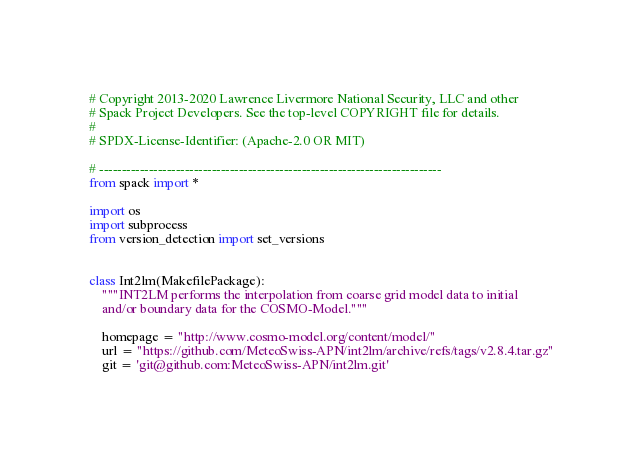Convert code to text. <code><loc_0><loc_0><loc_500><loc_500><_Python_># Copyright 2013-2020 Lawrence Livermore National Security, LLC and other
# Spack Project Developers. See the top-level COPYRIGHT file for details.
#
# SPDX-License-Identifier: (Apache-2.0 OR MIT)

# ----------------------------------------------------------------------------
from spack import *

import os
import subprocess
from version_detection import set_versions


class Int2lm(MakefilePackage):
    """INT2LM performs the interpolation from coarse grid model data to initial
    and/or boundary data for the COSMO-Model."""

    homepage = "http://www.cosmo-model.org/content/model/"
    url = "https://github.com/MeteoSwiss-APN/int2lm/archive/refs/tags/v2.8.4.tar.gz"
    git = 'git@github.com:MeteoSwiss-APN/int2lm.git'</code> 